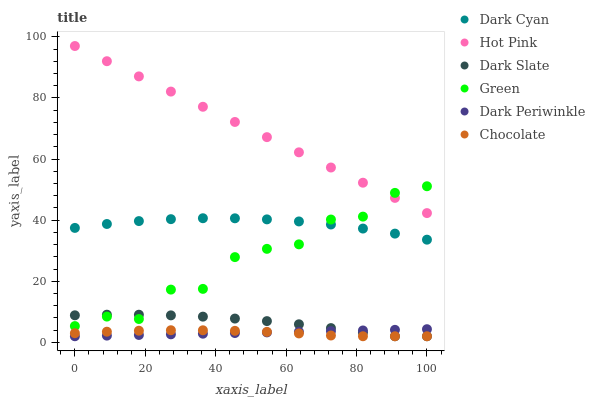Does Chocolate have the minimum area under the curve?
Answer yes or no. Yes. Does Hot Pink have the maximum area under the curve?
Answer yes or no. Yes. Does Dark Slate have the minimum area under the curve?
Answer yes or no. No. Does Dark Slate have the maximum area under the curve?
Answer yes or no. No. Is Dark Periwinkle the smoothest?
Answer yes or no. Yes. Is Green the roughest?
Answer yes or no. Yes. Is Chocolate the smoothest?
Answer yes or no. No. Is Chocolate the roughest?
Answer yes or no. No. Does Chocolate have the lowest value?
Answer yes or no. Yes. Does Green have the lowest value?
Answer yes or no. No. Does Hot Pink have the highest value?
Answer yes or no. Yes. Does Dark Slate have the highest value?
Answer yes or no. No. Is Dark Periwinkle less than Hot Pink?
Answer yes or no. Yes. Is Dark Cyan greater than Chocolate?
Answer yes or no. Yes. Does Dark Periwinkle intersect Chocolate?
Answer yes or no. Yes. Is Dark Periwinkle less than Chocolate?
Answer yes or no. No. Is Dark Periwinkle greater than Chocolate?
Answer yes or no. No. Does Dark Periwinkle intersect Hot Pink?
Answer yes or no. No. 